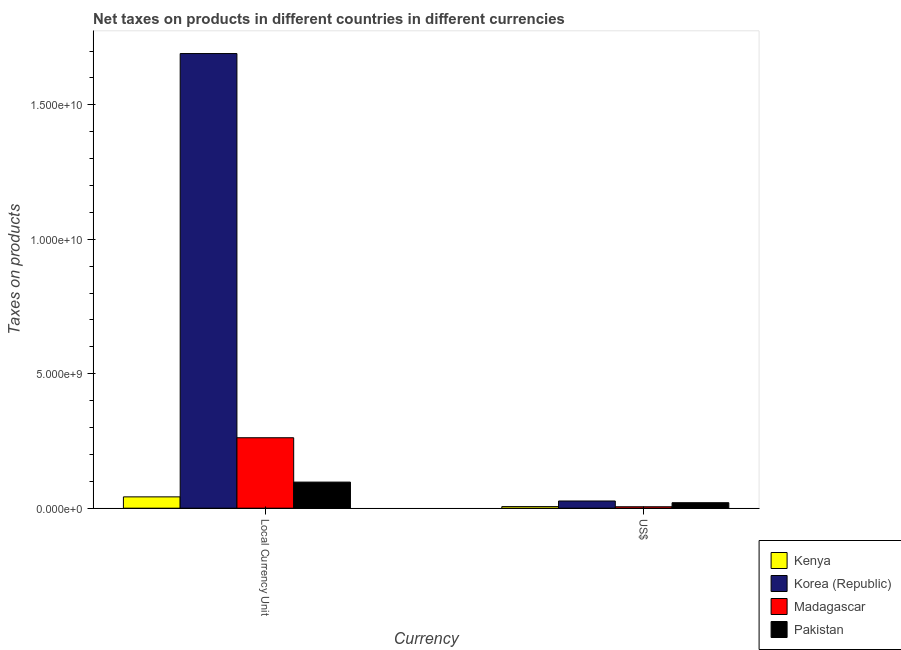How many different coloured bars are there?
Provide a succinct answer. 4. How many groups of bars are there?
Ensure brevity in your answer.  2. How many bars are there on the 1st tick from the left?
Make the answer very short. 4. How many bars are there on the 1st tick from the right?
Offer a terse response. 4. What is the label of the 2nd group of bars from the left?
Offer a very short reply. US$. What is the net taxes in constant 2005 us$ in Kenya?
Offer a terse response. 4.21e+08. Across all countries, what is the maximum net taxes in us$?
Provide a short and direct response. 2.68e+08. Across all countries, what is the minimum net taxes in us$?
Offer a very short reply. 5.31e+07. In which country was the net taxes in constant 2005 us$ minimum?
Your response must be concise. Kenya. What is the total net taxes in constant 2005 us$ in the graph?
Provide a short and direct response. 2.09e+1. What is the difference between the net taxes in us$ in Korea (Republic) and that in Pakistan?
Give a very brief answer. 6.41e+07. What is the difference between the net taxes in constant 2005 us$ in Korea (Republic) and the net taxes in us$ in Madagascar?
Provide a short and direct response. 1.69e+1. What is the average net taxes in constant 2005 us$ per country?
Ensure brevity in your answer.  5.23e+09. What is the difference between the net taxes in us$ and net taxes in constant 2005 us$ in Korea (Republic)?
Make the answer very short. -1.66e+1. What is the ratio of the net taxes in constant 2005 us$ in Pakistan to that in Korea (Republic)?
Provide a short and direct response. 0.06. Is the net taxes in us$ in Kenya less than that in Korea (Republic)?
Your response must be concise. Yes. In how many countries, is the net taxes in us$ greater than the average net taxes in us$ taken over all countries?
Keep it short and to the point. 2. What does the 1st bar from the left in US$ represents?
Provide a short and direct response. Kenya. Are all the bars in the graph horizontal?
Ensure brevity in your answer.  No. What is the difference between two consecutive major ticks on the Y-axis?
Provide a short and direct response. 5.00e+09. Does the graph contain any zero values?
Offer a terse response. No. Does the graph contain grids?
Ensure brevity in your answer.  No. Where does the legend appear in the graph?
Provide a succinct answer. Bottom right. How many legend labels are there?
Your answer should be very brief. 4. How are the legend labels stacked?
Your response must be concise. Vertical. What is the title of the graph?
Offer a very short reply. Net taxes on products in different countries in different currencies. Does "Guyana" appear as one of the legend labels in the graph?
Keep it short and to the point. No. What is the label or title of the X-axis?
Provide a short and direct response. Currency. What is the label or title of the Y-axis?
Give a very brief answer. Taxes on products. What is the Taxes on products in Kenya in Local Currency Unit?
Provide a short and direct response. 4.21e+08. What is the Taxes on products of Korea (Republic) in Local Currency Unit?
Make the answer very short. 1.69e+1. What is the Taxes on products of Madagascar in Local Currency Unit?
Your answer should be compact. 2.62e+09. What is the Taxes on products in Pakistan in Local Currency Unit?
Provide a short and direct response. 9.70e+08. What is the Taxes on products in Kenya in US$?
Offer a very short reply. 5.89e+07. What is the Taxes on products in Korea (Republic) in US$?
Provide a succinct answer. 2.68e+08. What is the Taxes on products in Madagascar in US$?
Make the answer very short. 5.31e+07. What is the Taxes on products of Pakistan in US$?
Make the answer very short. 2.04e+08. Across all Currency, what is the maximum Taxes on products in Kenya?
Provide a short and direct response. 4.21e+08. Across all Currency, what is the maximum Taxes on products of Korea (Republic)?
Ensure brevity in your answer.  1.69e+1. Across all Currency, what is the maximum Taxes on products in Madagascar?
Offer a very short reply. 2.62e+09. Across all Currency, what is the maximum Taxes on products of Pakistan?
Provide a short and direct response. 9.70e+08. Across all Currency, what is the minimum Taxes on products of Kenya?
Give a very brief answer. 5.89e+07. Across all Currency, what is the minimum Taxes on products in Korea (Republic)?
Your response must be concise. 2.68e+08. Across all Currency, what is the minimum Taxes on products of Madagascar?
Make the answer very short. 5.31e+07. Across all Currency, what is the minimum Taxes on products of Pakistan?
Your response must be concise. 2.04e+08. What is the total Taxes on products in Kenya in the graph?
Your response must be concise. 4.80e+08. What is the total Taxes on products in Korea (Republic) in the graph?
Give a very brief answer. 1.72e+1. What is the total Taxes on products of Madagascar in the graph?
Ensure brevity in your answer.  2.67e+09. What is the total Taxes on products of Pakistan in the graph?
Offer a terse response. 1.17e+09. What is the difference between the Taxes on products of Kenya in Local Currency Unit and that in US$?
Make the answer very short. 3.62e+08. What is the difference between the Taxes on products in Korea (Republic) in Local Currency Unit and that in US$?
Your answer should be compact. 1.66e+1. What is the difference between the Taxes on products of Madagascar in Local Currency Unit and that in US$?
Keep it short and to the point. 2.57e+09. What is the difference between the Taxes on products in Pakistan in Local Currency Unit and that in US$?
Offer a terse response. 7.66e+08. What is the difference between the Taxes on products of Kenya in Local Currency Unit and the Taxes on products of Korea (Republic) in US$?
Offer a terse response. 1.53e+08. What is the difference between the Taxes on products of Kenya in Local Currency Unit and the Taxes on products of Madagascar in US$?
Provide a succinct answer. 3.68e+08. What is the difference between the Taxes on products in Kenya in Local Currency Unit and the Taxes on products in Pakistan in US$?
Offer a very short reply. 2.17e+08. What is the difference between the Taxes on products in Korea (Republic) in Local Currency Unit and the Taxes on products in Madagascar in US$?
Provide a short and direct response. 1.69e+1. What is the difference between the Taxes on products of Korea (Republic) in Local Currency Unit and the Taxes on products of Pakistan in US$?
Provide a succinct answer. 1.67e+1. What is the difference between the Taxes on products in Madagascar in Local Currency Unit and the Taxes on products in Pakistan in US$?
Give a very brief answer. 2.42e+09. What is the average Taxes on products in Kenya per Currency?
Your answer should be very brief. 2.40e+08. What is the average Taxes on products of Korea (Republic) per Currency?
Your answer should be very brief. 8.59e+09. What is the average Taxes on products in Madagascar per Currency?
Your answer should be compact. 1.34e+09. What is the average Taxes on products of Pakistan per Currency?
Your answer should be compact. 5.87e+08. What is the difference between the Taxes on products in Kenya and Taxes on products in Korea (Republic) in Local Currency Unit?
Keep it short and to the point. -1.65e+1. What is the difference between the Taxes on products of Kenya and Taxes on products of Madagascar in Local Currency Unit?
Your answer should be very brief. -2.20e+09. What is the difference between the Taxes on products in Kenya and Taxes on products in Pakistan in Local Currency Unit?
Ensure brevity in your answer.  -5.49e+08. What is the difference between the Taxes on products of Korea (Republic) and Taxes on products of Madagascar in Local Currency Unit?
Give a very brief answer. 1.43e+1. What is the difference between the Taxes on products of Korea (Republic) and Taxes on products of Pakistan in Local Currency Unit?
Provide a succinct answer. 1.59e+1. What is the difference between the Taxes on products in Madagascar and Taxes on products in Pakistan in Local Currency Unit?
Offer a very short reply. 1.65e+09. What is the difference between the Taxes on products of Kenya and Taxes on products of Korea (Republic) in US$?
Give a very brief answer. -2.09e+08. What is the difference between the Taxes on products in Kenya and Taxes on products in Madagascar in US$?
Provide a short and direct response. 5.86e+06. What is the difference between the Taxes on products in Kenya and Taxes on products in Pakistan in US$?
Offer a very short reply. -1.45e+08. What is the difference between the Taxes on products of Korea (Republic) and Taxes on products of Madagascar in US$?
Your answer should be compact. 2.15e+08. What is the difference between the Taxes on products in Korea (Republic) and Taxes on products in Pakistan in US$?
Provide a succinct answer. 6.41e+07. What is the difference between the Taxes on products in Madagascar and Taxes on products in Pakistan in US$?
Provide a succinct answer. -1.51e+08. What is the ratio of the Taxes on products of Kenya in Local Currency Unit to that in US$?
Ensure brevity in your answer.  7.14. What is the ratio of the Taxes on products of Korea (Republic) in Local Currency Unit to that in US$?
Your answer should be compact. 63.12. What is the ratio of the Taxes on products in Madagascar in Local Currency Unit to that in US$?
Your response must be concise. 49.37. What is the ratio of the Taxes on products of Pakistan in Local Currency Unit to that in US$?
Offer a terse response. 4.76. What is the difference between the highest and the second highest Taxes on products of Kenya?
Make the answer very short. 3.62e+08. What is the difference between the highest and the second highest Taxes on products in Korea (Republic)?
Provide a short and direct response. 1.66e+1. What is the difference between the highest and the second highest Taxes on products of Madagascar?
Offer a terse response. 2.57e+09. What is the difference between the highest and the second highest Taxes on products of Pakistan?
Your answer should be very brief. 7.66e+08. What is the difference between the highest and the lowest Taxes on products of Kenya?
Keep it short and to the point. 3.62e+08. What is the difference between the highest and the lowest Taxes on products in Korea (Republic)?
Offer a very short reply. 1.66e+1. What is the difference between the highest and the lowest Taxes on products of Madagascar?
Your answer should be very brief. 2.57e+09. What is the difference between the highest and the lowest Taxes on products of Pakistan?
Make the answer very short. 7.66e+08. 